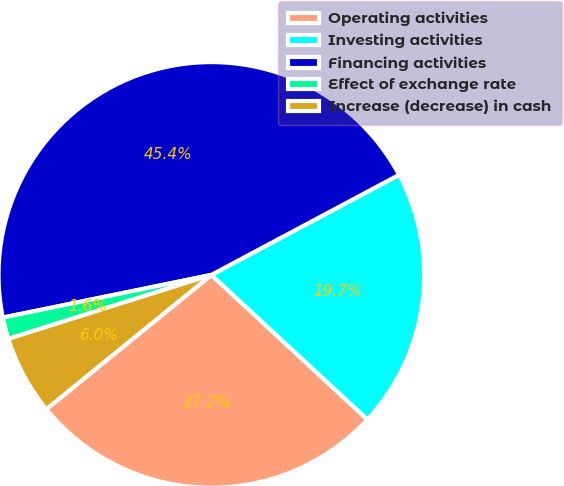<chart> <loc_0><loc_0><loc_500><loc_500><pie_chart><fcel>Operating activities<fcel>Investing activities<fcel>Financing activities<fcel>Effect of exchange rate<fcel>Increase (decrease) in cash<nl><fcel>27.23%<fcel>19.69%<fcel>45.42%<fcel>1.64%<fcel>6.02%<nl></chart> 